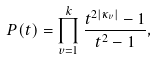Convert formula to latex. <formula><loc_0><loc_0><loc_500><loc_500>P ( t ) = \prod _ { v = 1 } ^ { k } \frac { t ^ { 2 | \kappa _ { v } | } - 1 } { t ^ { 2 } - 1 } ,</formula> 